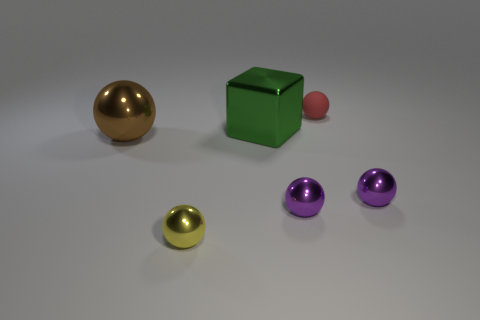Are there any other things that have the same material as the red sphere?
Offer a very short reply. No. Are there any rubber things of the same color as the big metallic block?
Make the answer very short. No. There is a green metallic thing that is the same size as the brown metallic ball; what is its shape?
Keep it short and to the point. Cube. There is a metal thing behind the big brown thing; does it have the same color as the rubber ball?
Offer a terse response. No. What number of things are either things that are to the left of the yellow metal ball or red balls?
Your response must be concise. 2. Are there more tiny shiny objects on the right side of the small yellow metallic ball than yellow balls that are behind the green metal block?
Provide a short and direct response. Yes. Is the red thing made of the same material as the big brown thing?
Your answer should be compact. No. There is a object that is both in front of the red matte ball and behind the big brown metal object; what is its shape?
Offer a very short reply. Cube. There is a green object that is the same material as the yellow sphere; what is its shape?
Your response must be concise. Cube. Is there a red cylinder?
Your response must be concise. No. 